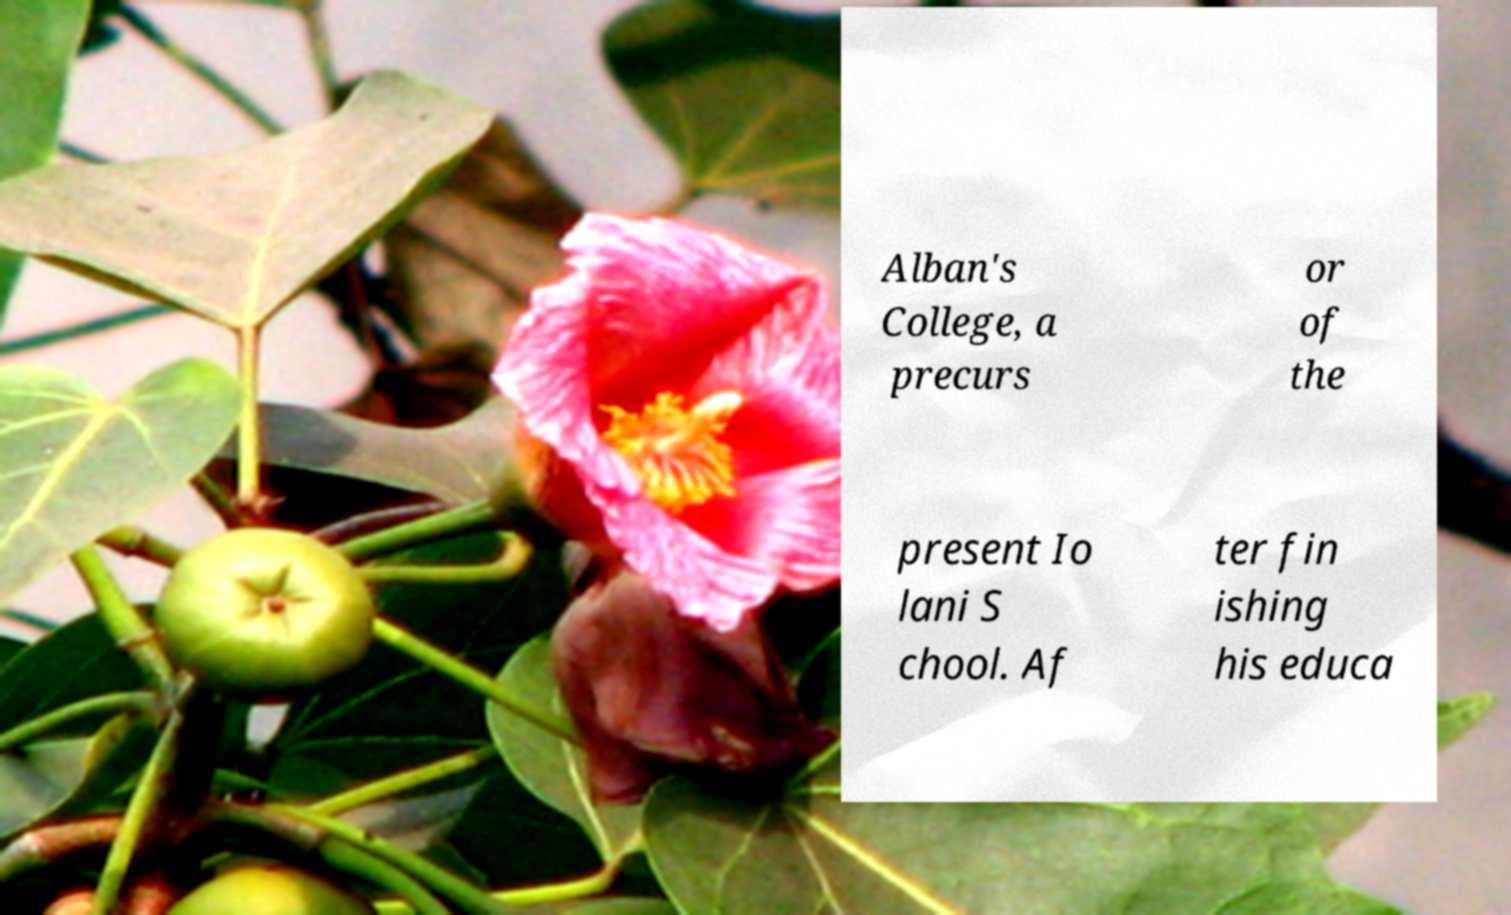I need the written content from this picture converted into text. Can you do that? Alban's College, a precurs or of the present Io lani S chool. Af ter fin ishing his educa 